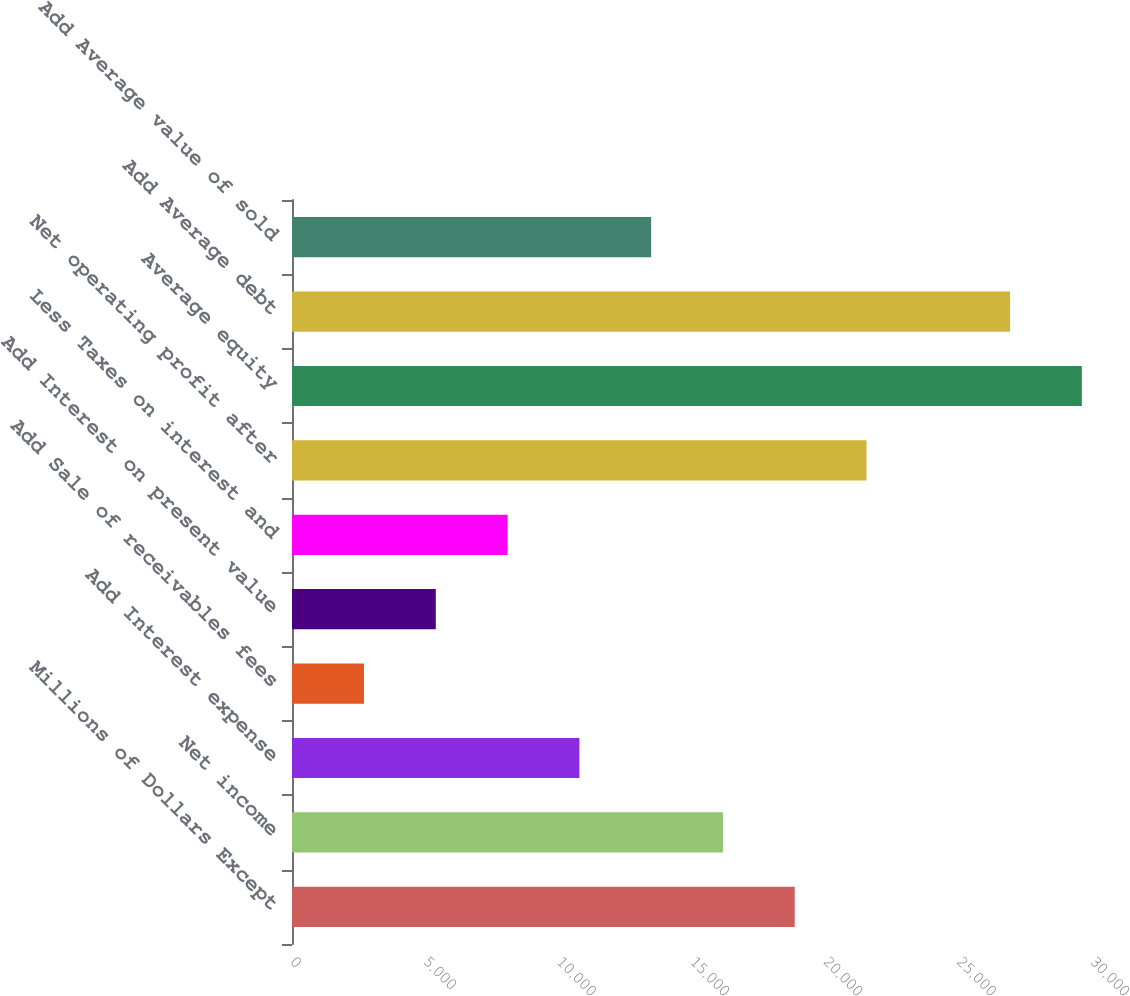Convert chart. <chart><loc_0><loc_0><loc_500><loc_500><bar_chart><fcel>Millions of Dollars Except<fcel>Net income<fcel>Add Interest expense<fcel>Add Sale of receivables fees<fcel>Add Interest on present value<fcel>Less Taxes on interest and<fcel>Net operating profit after<fcel>Average equity<fcel>Add Average debt<fcel>Add Average value of sold<nl><fcel>18852.2<fcel>16160.3<fcel>10776.4<fcel>2700.63<fcel>5392.56<fcel>8084.49<fcel>21544.1<fcel>29619.9<fcel>26928<fcel>13468.4<nl></chart> 